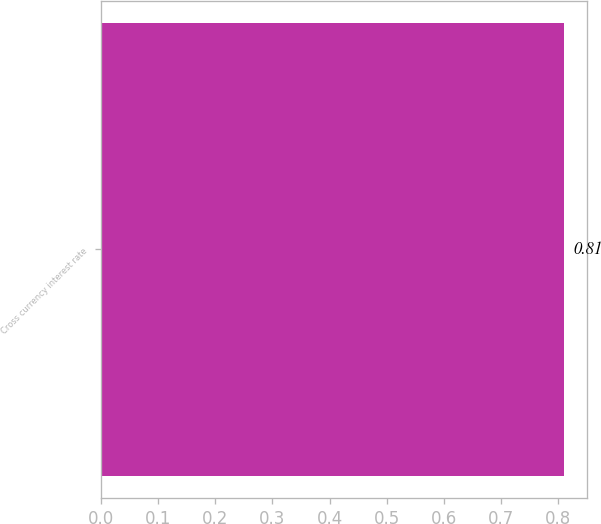<chart> <loc_0><loc_0><loc_500><loc_500><bar_chart><fcel>Cross currency interest rate<nl><fcel>0.81<nl></chart> 